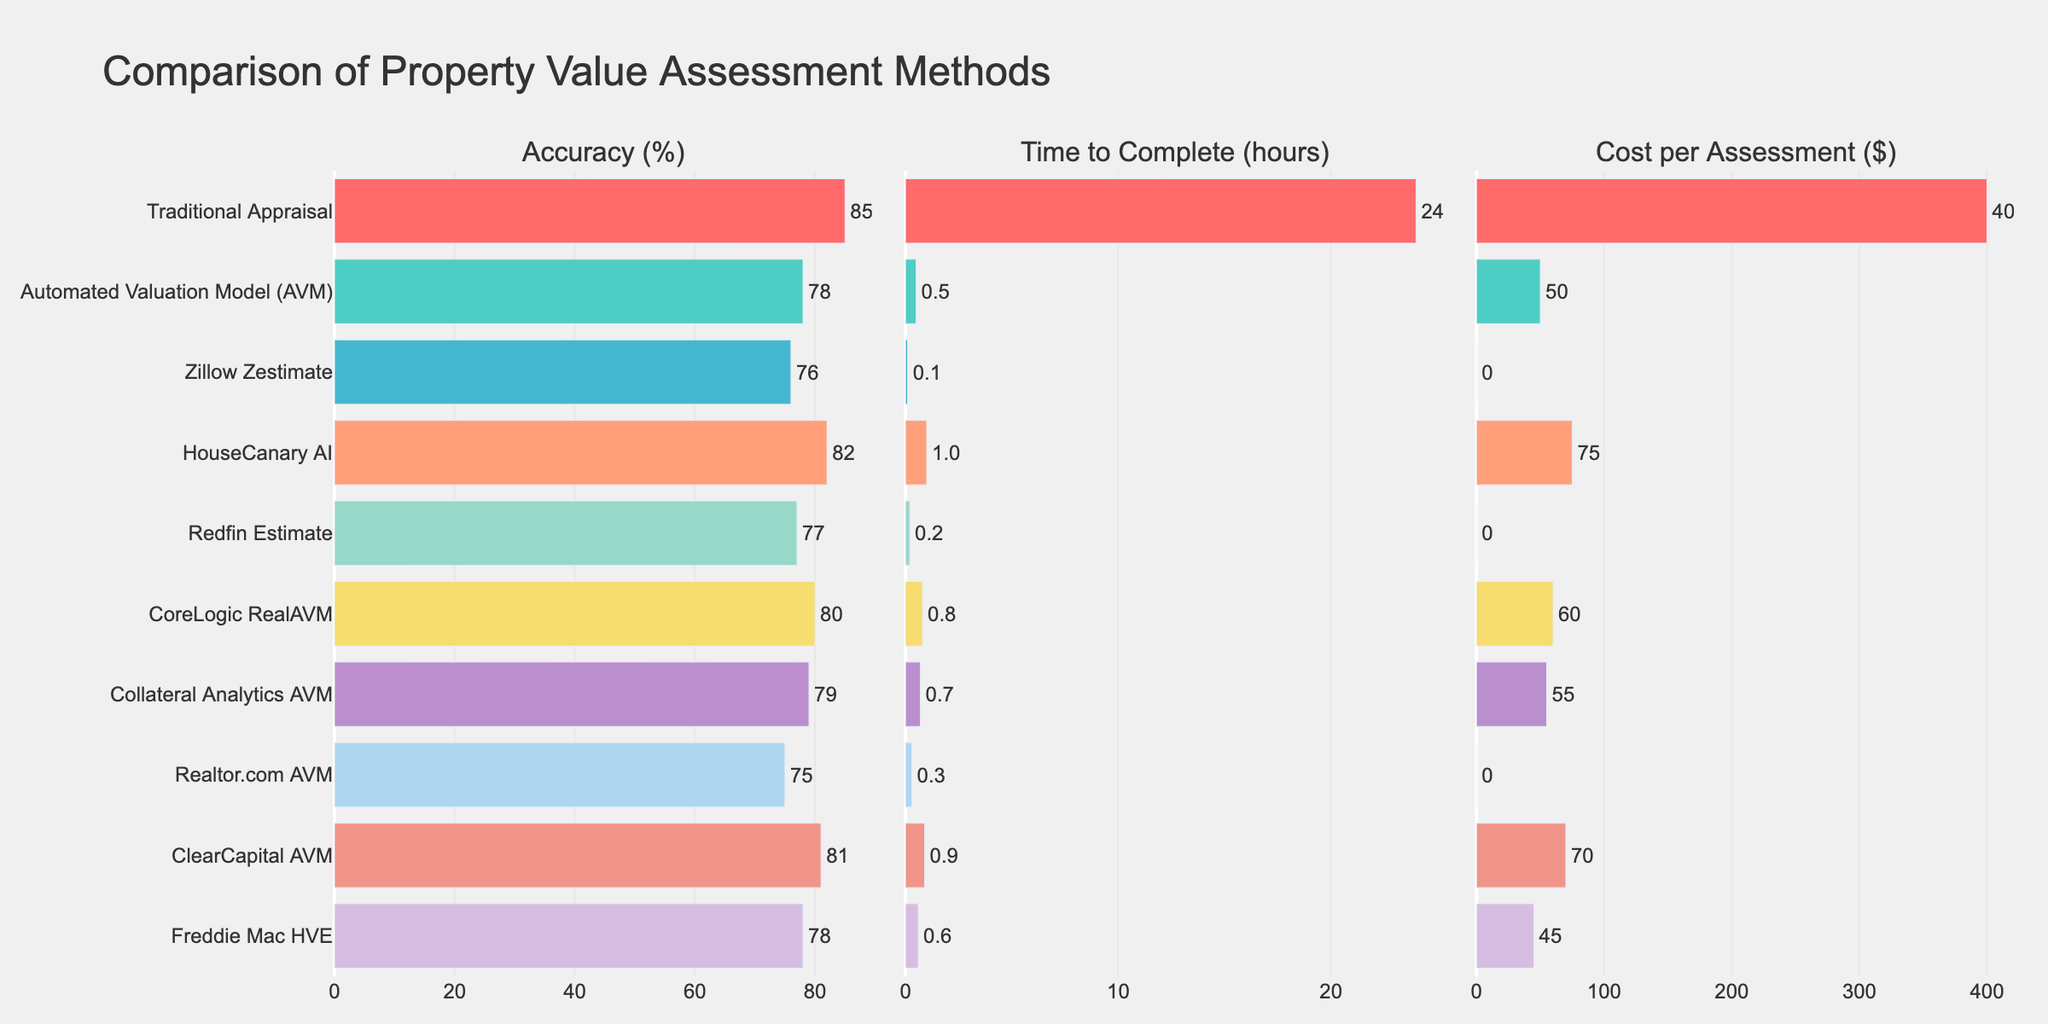Which method has the highest accuracy and what is its value? The traditional appraisal method has the highest accuracy. From the figure, it is observed that the bar for traditional appraisal is the longest in terms of accuracy.
Answer: Traditional Appraisal, 85% Which method has the lowest cost per assessment and what is its value? Zillow Zestimate, Redfin Estimate, and Realtor.com AVM all have bars at zero cost per assessment, indicating they are free.
Answer: Zillow Zestimate, Redfin Estimate, Realtor.com AVM, $0 What is the time difference between the fastest and the slowest method to complete? The figure shows that the fastest method is Zillow Zestimate with 0.1 hours and the slowest is the Traditional Appraisal with 24 hours. The time difference is 24 - 0.1 = 23.9 hours.
Answer: 23.9 hours Which AI-powered method has the closest accuracy to the traditional appraisal? HouseCanary AI has an accuracy of 82%, which is the closest to Traditional Appraisal's 85%.
Answer: HouseCanary AI How does the cost of CoreLogic RealAVM compare to HouseCanary AI? CoreLogic RealAVM has a cost of $60 and HouseCanary AI has a cost of $75. The difference is $75 - $60 = $15, so HouseCanary AI is $15 more expensive.
Answer: HouseCanary AI is $15 more expensive What is the average accuracy of all AI-powered methods? The accuracies for AVM methods listed are 78, 76, 82, 77, 80, 79, 75, 81, 78. Summing these gives 656. Dividing by the number of methods (9) yields an average of 656/9 ≈ 72.89.
Answer: 72.89% How does the accuracy of CoreLogic RealAVM compare to Collateral Analytics AVM? CoreLogic RealAVM has an accuracy of 80% and Collateral Analytics AVM has an accuracy of 79%. CoreLogic RealAVM is 1% more accurate.
Answer: CoreLogic RealAVM is 1% more accurate Which method provides the best balance of accuracy and low cost according to the figure? HouseCanary AI with an accuracy of 82% and a cost of $75 appears to offer a good balance of high accuracy and relatively low cost compared to other methods with similar accuracies.
Answer: HouseCanary AI Which method has the longest bar in terms of cost per assessment? Traditional Appraisal has the longest bar for cost per assessment at $400, making it the most expensive method.
Answer: Traditional Appraisal What is the combined cost for an assessment using CoreLogic RealAVM and ClearCapital AVM? CoreLogic RealAVM costs $60 and ClearCapital AVM costs $70. The combined cost is $60 + $70 = $130.
Answer: $130 